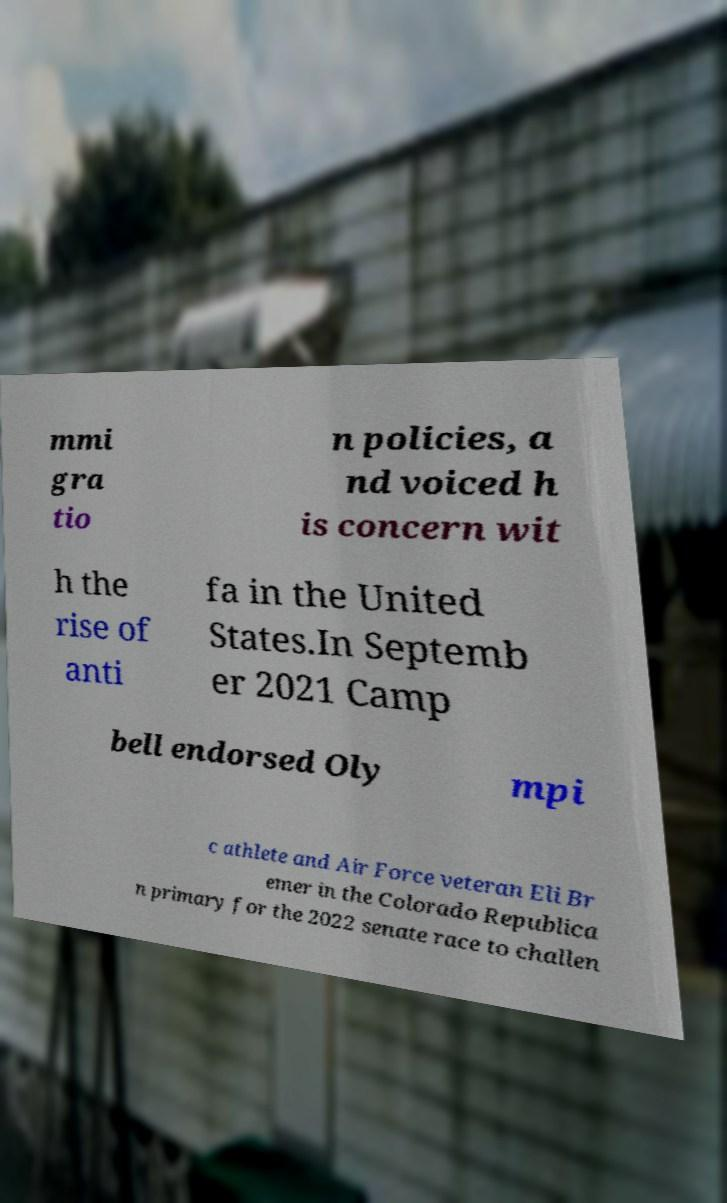Can you read and provide the text displayed in the image?This photo seems to have some interesting text. Can you extract and type it out for me? mmi gra tio n policies, a nd voiced h is concern wit h the rise of anti fa in the United States.In Septemb er 2021 Camp bell endorsed Oly mpi c athlete and Air Force veteran Eli Br emer in the Colorado Republica n primary for the 2022 senate race to challen 